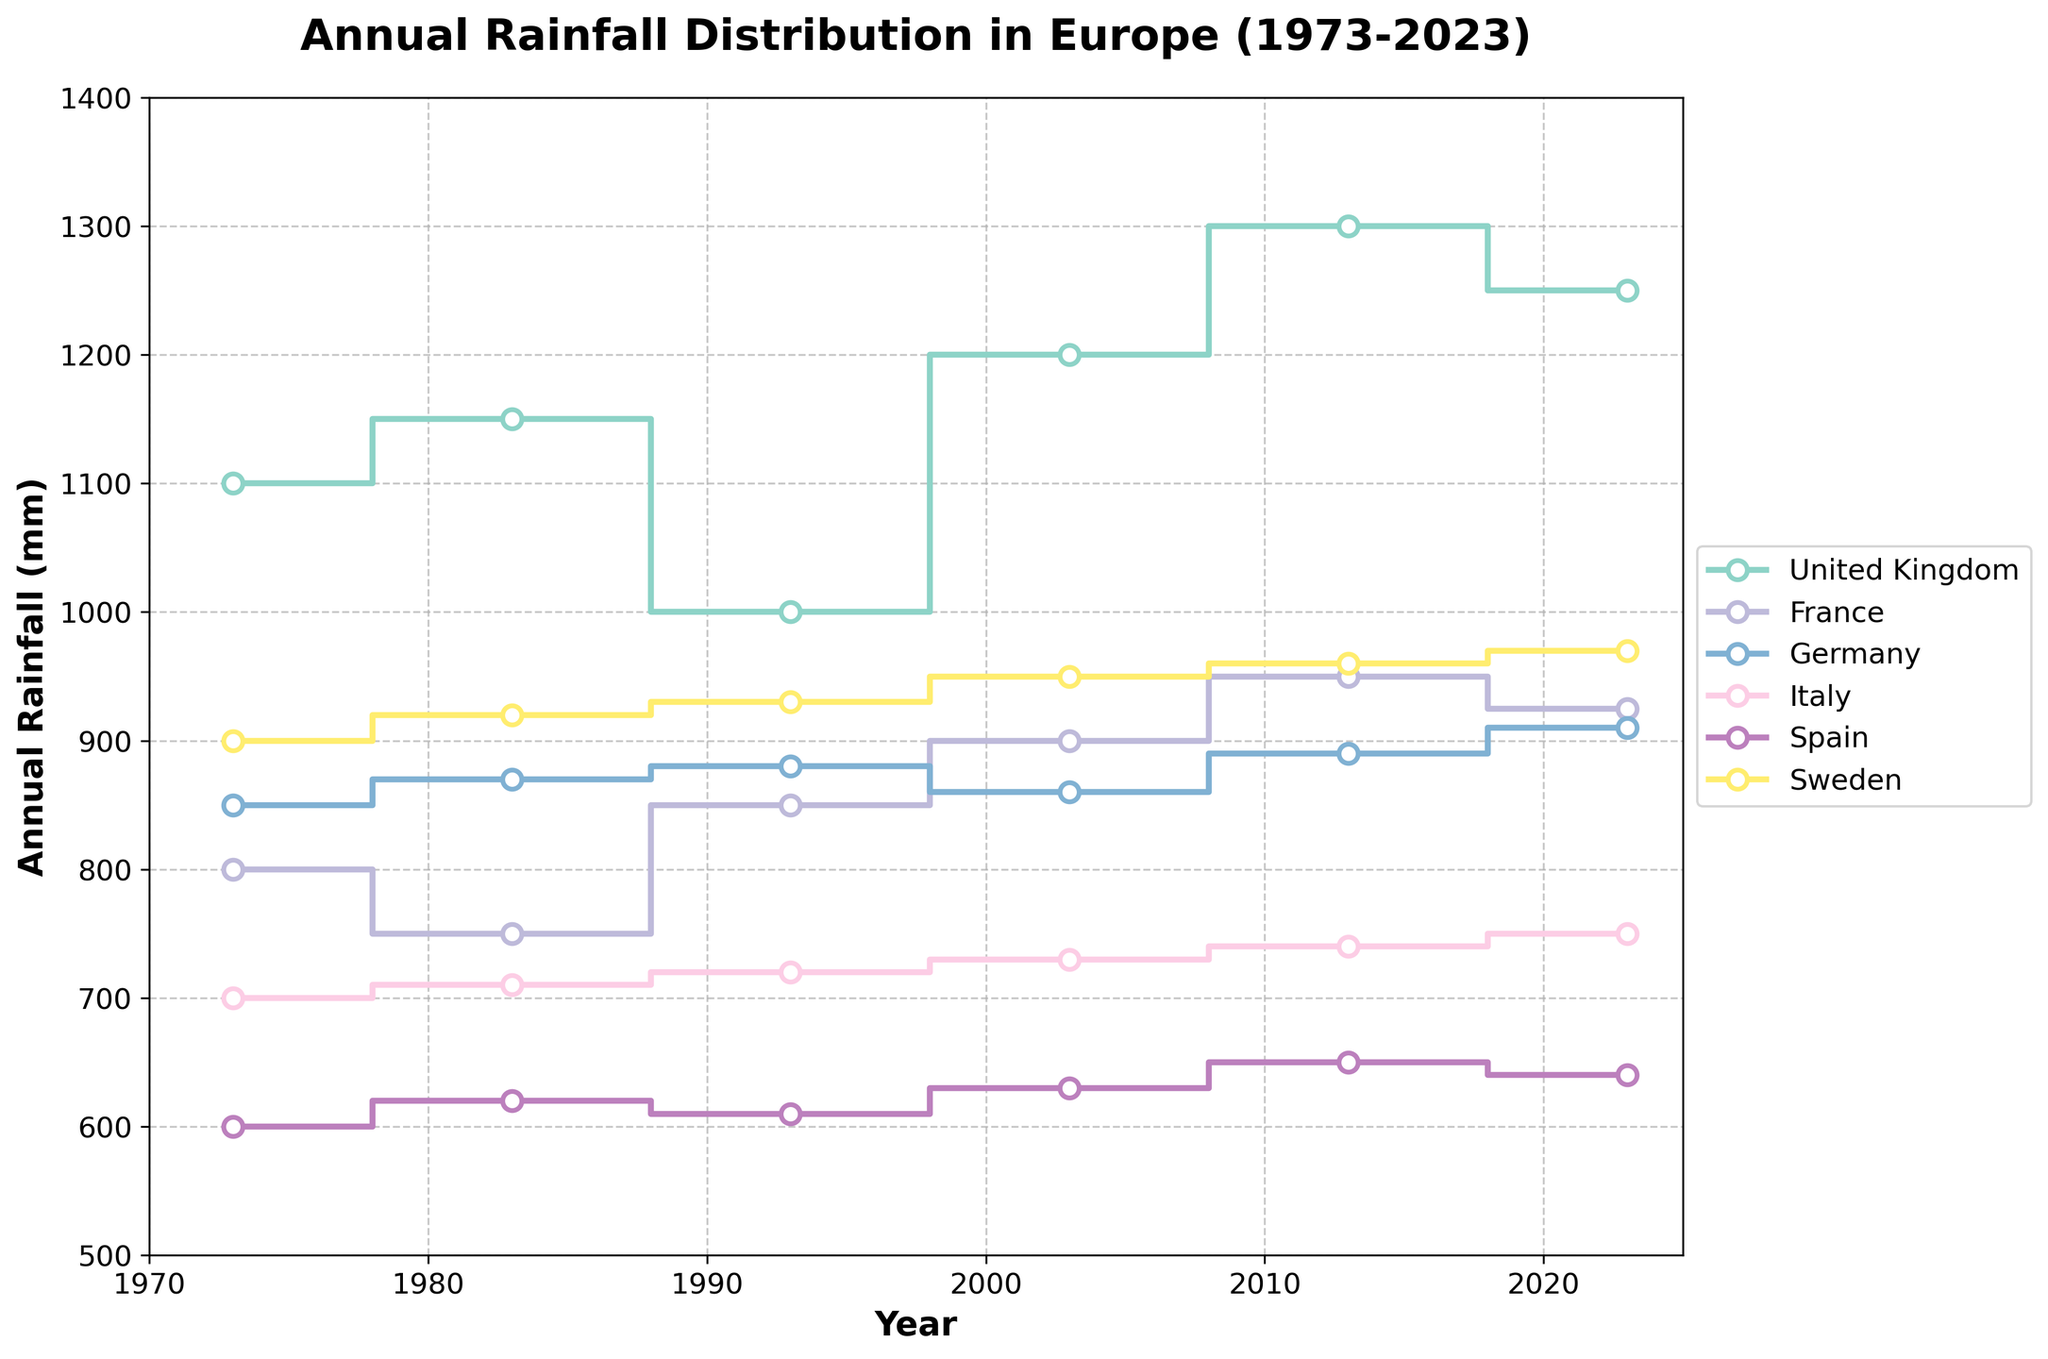How many countries are represented in the plot? There are 6 unique countries plotted. Each country is represented by a different colored line: United Kingdom, France, Germany, Italy, Spain, and Sweden.
Answer: 6 What is the title of the plot? The title can be found at the top of the plot. It reads "Annual Rainfall Distribution in Europe (1973-2023)."
Answer: "Annual Rainfall Distribution in Europe (1973-2023)" Which country had the highest annual rainfall in 2023? To determine this, look at the values in 2023 for all countries. The United Kingdom has the highest annual rainfall, at 1250 mm.
Answer: United Kingdom How does France's rainfall trend from 1973 to 2023? The trend of France can be observed by following the line: starting from 800 mm in 1973, the rainfall slightly decreases to 750 mm in 1983, then increases to 925 mm in 2023.
Answer: Increasing trend Which country shows the most stable annual rainfall over the 50 years? The most stable trend can be determined by observing the fluctuations in the lines. Italy shows minimal changes from 700 mm in 1973 to 750 mm in 2023.
Answer: Italy What is the difference in annual rainfall between Sweden and Spain in 2023? The annual rainfall for Sweden in 2023 is 970 mm, and for Spain, it is 640 mm. The difference is 970 mm - 640 mm = 330 mm.
Answer: 330 mm Between which years did the United Kingdom see the largest increase in annual rainfall? Looking at the step plot for the United Kingdom, the largest increase occurs between 1993 and 2003, from 1000 mm to 1200 mm.
Answer: 1993 to 2003 In which decade did Germany experience its lowest annual rainfall? By examining the line for Germany, the lowest annual rainfall is seen in 2003 at 860 mm.
Answer: 2003 What is the average annual rainfall for Italy from the offered data points? Adding the values: 700, 710, 720, 730, 740, and 750 mm, we get 4350 mm. Dividing by the 6 data points: 4350 / 6 = 725 mm.
Answer: 725 mm Is there any year where all countries experienced a rainfall above 900 mm? By tracing all lines, no single year shows rainfall above 900 mm for all countries.
Answer: No 